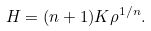Convert formula to latex. <formula><loc_0><loc_0><loc_500><loc_500>H = ( n + 1 ) K \rho ^ { 1 / n } .</formula> 